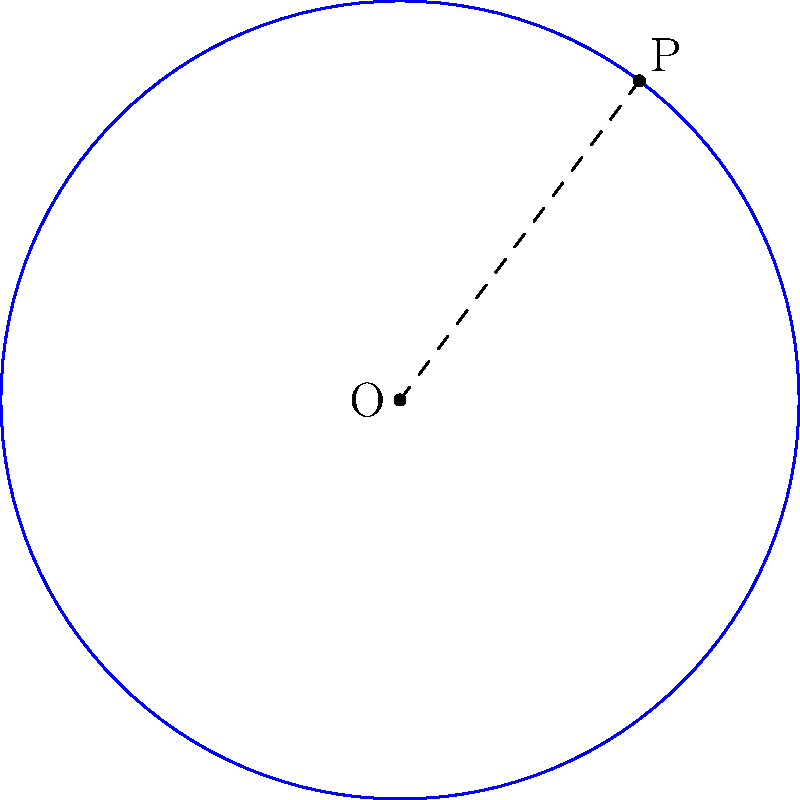During a nostalgic conversation about your Columbia University days with Arlene Lozano, you both reminisce about a challenging geometry problem from your shared math class. The problem involves a circle with center O at (2, 3) and a point P (5, 7) on its circumference. What is the equation of this circle? Let's approach this step-by-step:

1) The general equation of a circle is $$(x-h)^2 + (y-k)^2 = r^2$$
   where (h,k) is the center and r is the radius.

2) We're given the center O(2,3), so h = 2 and k = 3.

3) To find r, we need to calculate the distance between O and P:
   $$r = \sqrt{(x_P-x_O)^2 + (y_P-y_O)^2}$$
   $$r = \sqrt{(5-2)^2 + (7-3)^2}$$
   $$r = \sqrt{3^2 + 4^2} = \sqrt{9 + 16} = \sqrt{25} = 5$$

4) Now we can substitute these values into the general equation:
   $$(x-2)^2 + (y-3)^2 = 5^2$$

5) Simplify:
   $$(x-2)^2 + (y-3)^2 = 25$$

This is the equation of the circle.
Answer: $(x-2)^2 + (y-3)^2 = 25$ 